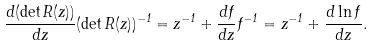<formula> <loc_0><loc_0><loc_500><loc_500>\frac { d ( \det R ( z ) ) } { d z } ( \det R ( z ) ) ^ { - 1 } = z ^ { - 1 } + \frac { d f } { d z } f ^ { - 1 } = z ^ { - 1 } + \frac { d \ln f } { d z } .</formula> 